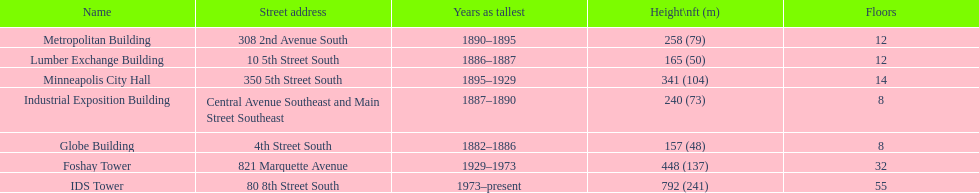Which building has the same number of floors as the lumber exchange building? Metropolitan Building. 